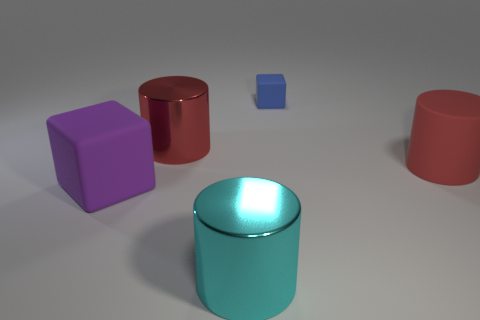Subtract all big matte cylinders. How many cylinders are left? 2 Subtract all blocks. How many objects are left? 3 Add 4 red rubber objects. How many red rubber objects exist? 5 Add 4 big cyan metal cylinders. How many objects exist? 9 Subtract all red cylinders. How many cylinders are left? 1 Subtract 0 green cylinders. How many objects are left? 5 Subtract 2 cylinders. How many cylinders are left? 1 Subtract all purple cubes. Subtract all red cylinders. How many cubes are left? 1 Subtract all yellow spheres. How many purple cylinders are left? 0 Subtract all metallic cylinders. Subtract all small blue cubes. How many objects are left? 2 